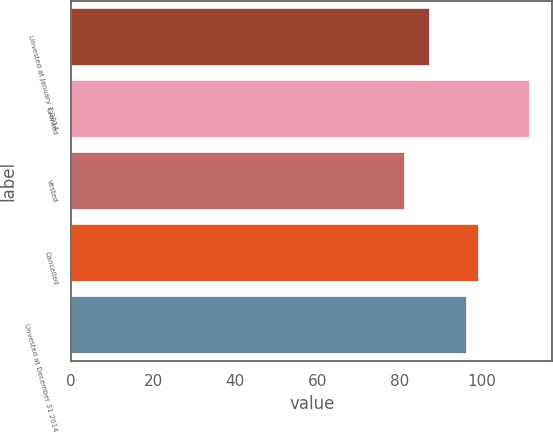Convert chart to OTSL. <chart><loc_0><loc_0><loc_500><loc_500><bar_chart><fcel>Unvested at January 1 2014<fcel>Granted<fcel>Vested<fcel>Cancelled<fcel>Unvested at December 31 2014<nl><fcel>87.29<fcel>111.64<fcel>81.32<fcel>99.39<fcel>96.36<nl></chart> 